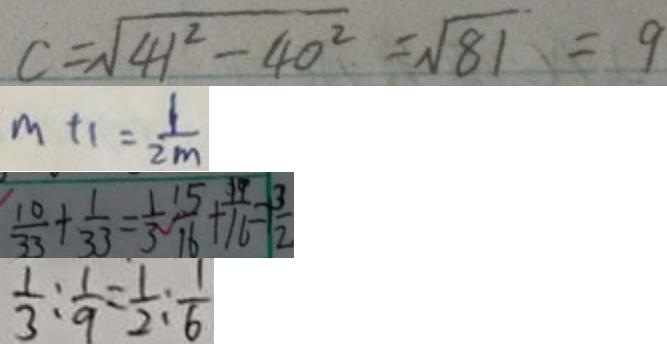Convert formula to latex. <formula><loc_0><loc_0><loc_500><loc_500>c = \sqrt { 4 1 ^ { 2 } - 4 0 ^ { 2 } } = \sqrt { 8 1 } = 9 
 m + 1 = \frac { 1 } { 2 m } 
 \frac { 1 0 } { 3 3 } + \frac { 1 } { 3 3 } = \frac { 1 } { 3 } \frac { 1 5 } { 1 6 } + \frac { 1 9 } { 1 6 } = \frac { 3 } { 2 } 
 \frac { 1 } { 3 } : \frac { 1 } { 9 } = \frac { 1 } { 2 } : \frac { 1 } { 6 }</formula> 